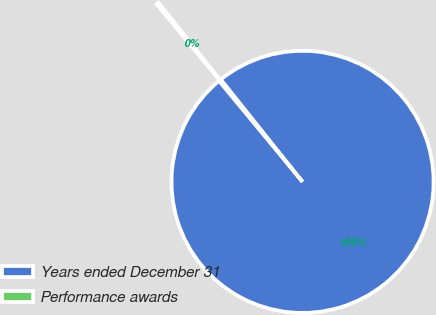Convert chart. <chart><loc_0><loc_0><loc_500><loc_500><pie_chart><fcel>Years ended December 31<fcel>Performance awards<nl><fcel>99.72%<fcel>0.28%<nl></chart> 